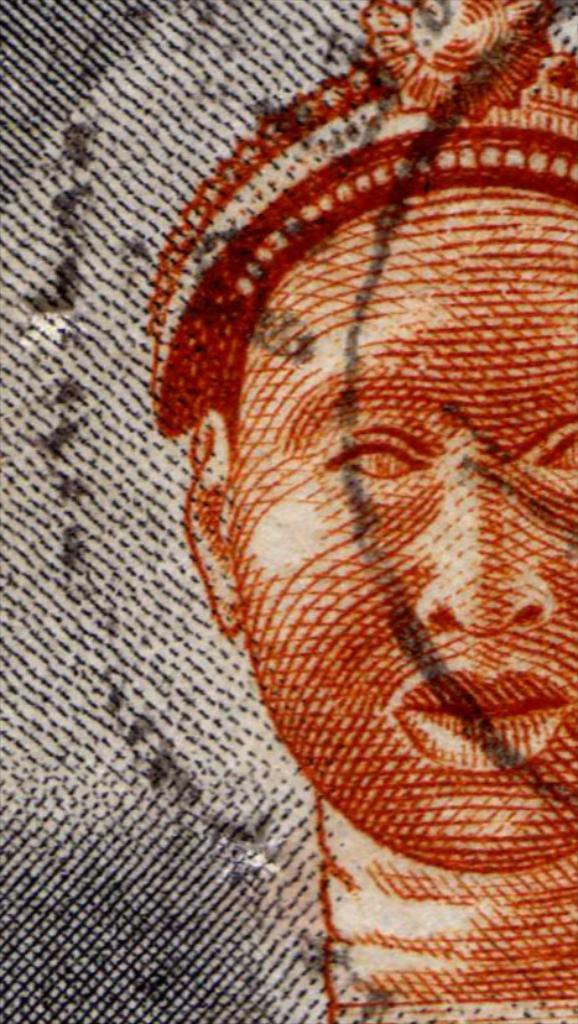What type of artwork is shown in the image? The image is a painting. Can you describe the subject matter of the painting? There is a person depicted in the painting. How many turkeys are present in the painting? There are no turkeys depicted in the painting; it features a person. What type of star can be seen in the painting? There is no star present in the painting; it is a painting of a person. 